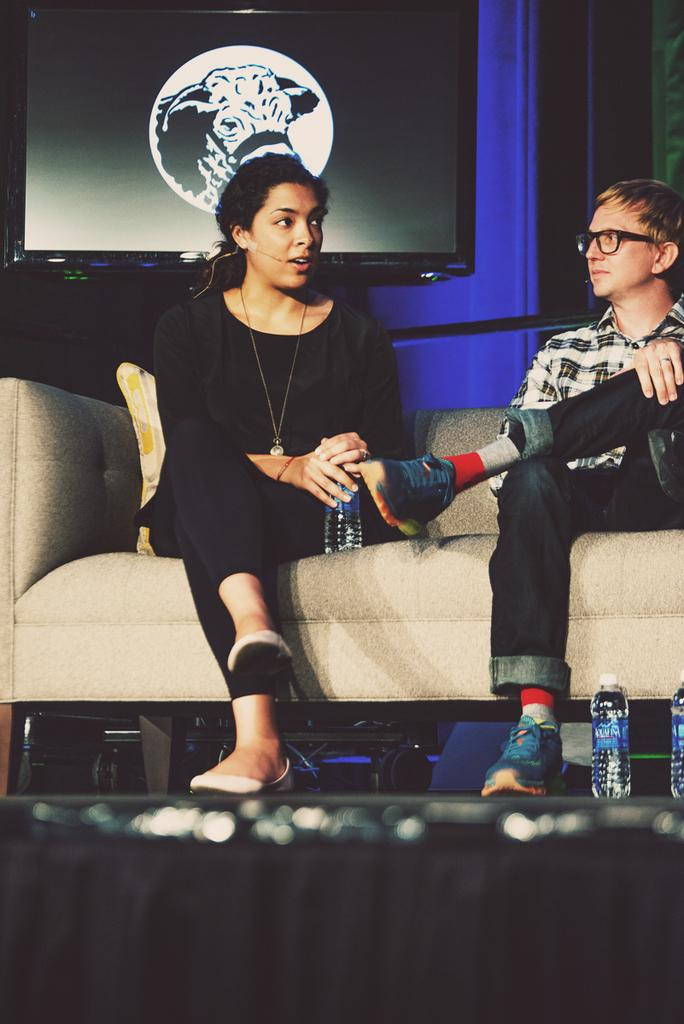How many people are in the image? There are two people in the image, a woman and a man. What are the woman and the man doing in the image? Both the woman and the man are sitting on a sofa. What is the woman holding in the image? The woman is holding a bottle. Are there any other bottles visible in the image? Yes, there are bottles in the image. What can be seen in the background of the image? There is a screen in the background of the image. What is visible on the floor in the image? The floor is visible in the image. What type of country is depicted in the image? There is no country depicted in the image; it features a woman and a man sitting on a sofa. How does the rainstorm affect the people in the image? There is no rainstorm present in the image; it is an indoor scene with a woman and a man sitting on a sofa. 